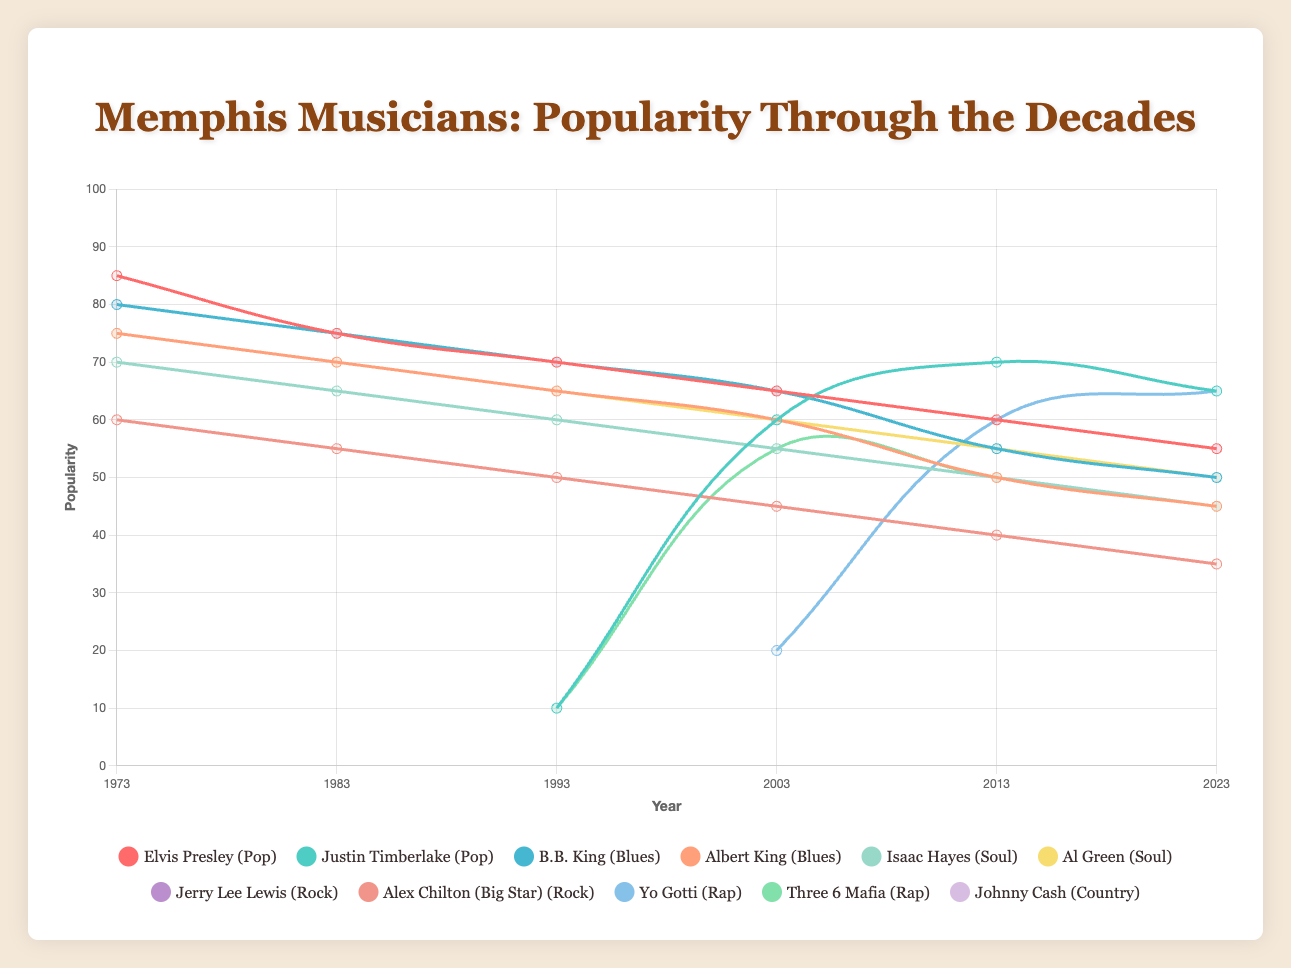How has the popularity of Elvis Presley changed over the last 50 years? To answer this, observe the trend of Elvis Presley's popularity scores from 1973 to 2023. The popularity decreased from 85 in 1973, steadily declining to 55 by 2023.
Answer: Decreased from 85 to 55 Who was more popular in 2023, Yo Gotti or Three 6 Mafia? Look at the final values in 2023 for both Yo Gotti and Three 6 Mafia. Yo Gotti's popularity is 65, and Three 6 Mafia's is 45. Therefore, Yo Gotti was more popular.
Answer: Yo Gotti How did the Blues genre's overall popularity change from 1973 to 2023? Combine the data for B.B. King and Albert King. B.B. King goes from 80 to 50, and Albert King from 75 to 45. The overall trend shows a decrease in popularity for both artists.
Answer: Decreased Which artist had the highest popularity score in 1993? Compare the popularity scores of all artists in 1993. Elvis Presley had one of the highest scores with 70, matched by B.B. King.
Answer: Elvis Presley and B.B. King (tie) Whose popularity increased more between 2003 and 2023, Justin Timberlake or Yo Gotti? Compare the change in popularity scores from 2003 to 2023. Justin Timberlake's increase is from 60 to 65 (5 points), while Yo Gotti's is from 20 to 65 (45 points). Thus, Yo Gotti's popularity increased more.
Answer: Yo Gotti Which genre's artists have shown consistently declining popularity trends? Look at the overall trends for each genre's artists. Blues (B.B. King, Albert King) and Soul (Isaac Hayes, Al Green) show consistent declines over the years.
Answer: Blues and Soul How does the 2023 popularity of Justin Timberlake compare to his 2003 popularity? Check Justin Timberlake's scores in 2003 (60) and 2023 (65). There is a slight increase in popularity.
Answer: Increased By how much did Johnny Cash's popularity decline from 1973 to 2023? Calculate the difference between Johnny Cash's popularity in 1973 (75) and 2023 (50). The decline is 75 - 50 = 25.
Answer: 25 points Which year marks the first significant rise in popularity for Yo Gotti, and by how much did his popularity increase? Note the changes in Yo Gotti's popularity scores. The first significant rise is in 2013, going from 20 in 2003 to 60 in 2013, an increase of 40 points.
Answer: 2013, increased by 40 points What is the average popularity of B.B. King over the observed years? Add up B.B. King's popularity scores for all years: 80, 75, 70, 65, 55, 50. The total is 395. Divide this by the number of observations (6 years). 395 / 6 = 65.83.
Answer: 65.83 